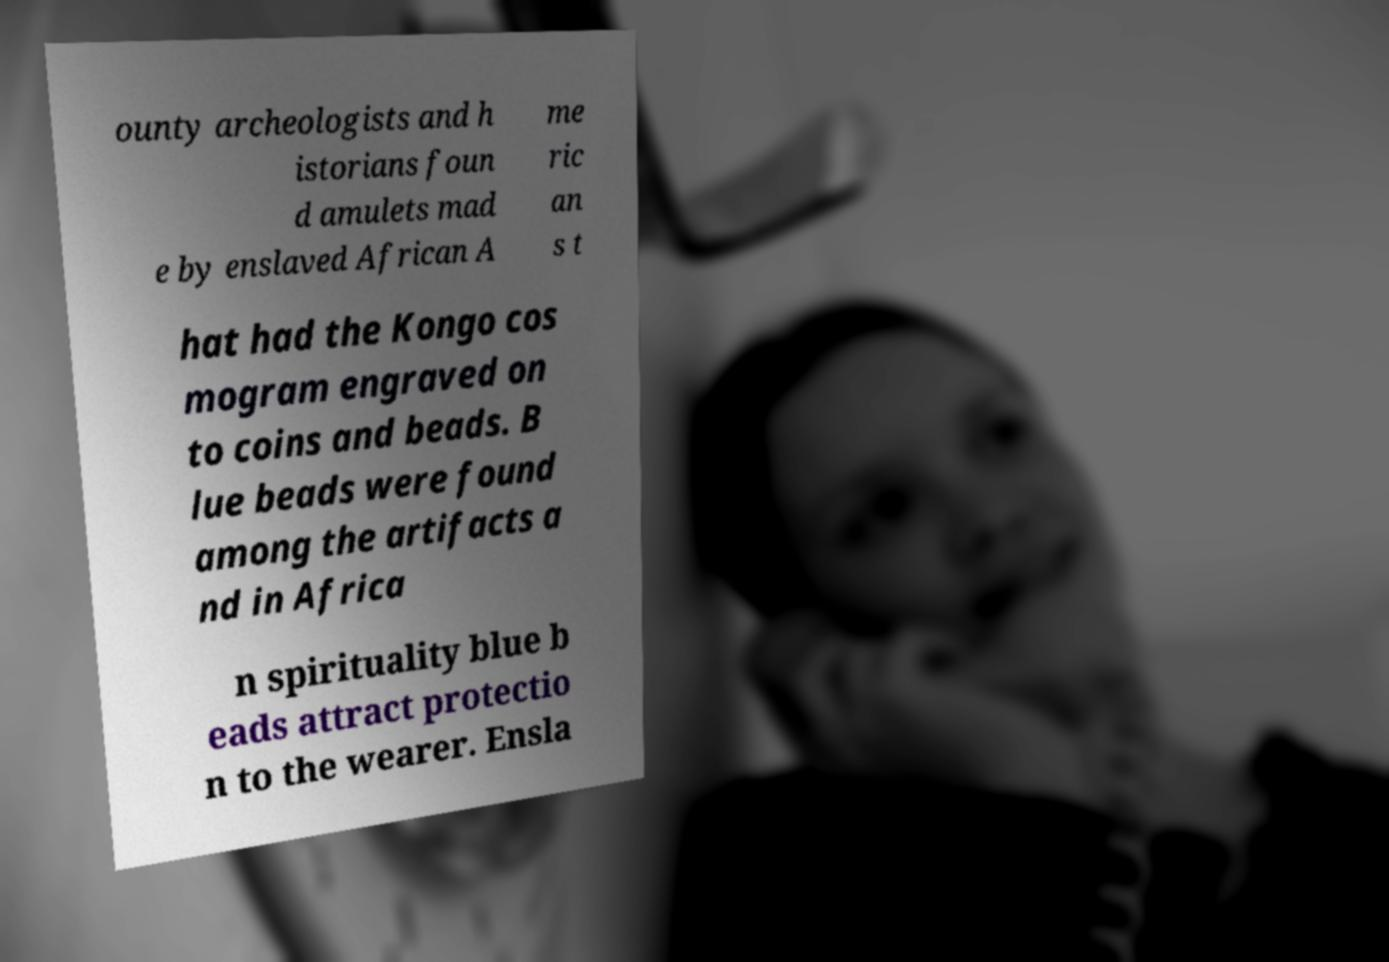There's text embedded in this image that I need extracted. Can you transcribe it verbatim? ounty archeologists and h istorians foun d amulets mad e by enslaved African A me ric an s t hat had the Kongo cos mogram engraved on to coins and beads. B lue beads were found among the artifacts a nd in Africa n spirituality blue b eads attract protectio n to the wearer. Ensla 